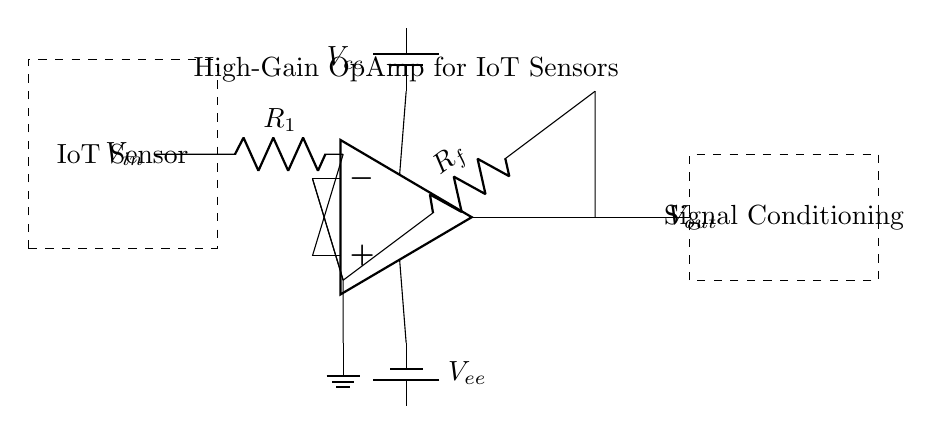What is the input voltage labeled as in the circuit? The input voltage in the circuit is labeled as V_in, which is indicated on the left side of the diagram, showing where the input signal connects to the circuit.
Answer: V_in What components are used in the circuit? The components in the circuit include a high-gain operational amplifier, a resistor labeled R1, and a resistor labeled R_f, along with power supplies indicated as V_cc and V_ee.
Answer: OpAmp, R1, R_f, V_cc, V_ee What is the configuration of the operational amplifier in this circuit? The operational amplifier is configured in a feedback arrangement, where R_f provides negative feedback from the output to the inverting input. This configuration is typical for amplifying signals.
Answer: Inverting What is the purpose of the feedback resistor R_f? The feedback resistor R_f controls the gain of the operational amplifier. By adjusting R_f, you influence how much of the output voltage is fed back to the inverting input, thereby setting the gain level for the input signal.
Answer: To set gain What do the dashed rectangles represent in the circuit? The dashed rectangles in the circuit represent two specific functional blocks: one labeled "IoT Sensor" on the left, which likely generates the input signal, and another labeled "Signal Conditioning" on the right, indicating the output processing section.
Answer: IoT Sensor and Signal Conditioning How do the power supplies V_cc and V_ee affect the op-amp? The power supplies V_cc and V_ee provide the necessary voltage levels for the operational amplifier to function properly. V_cc powers the positive side and V_ee powers the negative side, defining the range of the output voltage swing.
Answer: Powering the op-amp What is the output voltage in the circuit is labeled as? The output voltage in the circuit is labeled as V_out, which is shown on the right side of the diagram, indicating where the amplified signal is available for the next stage in the circuit.
Answer: V_out 